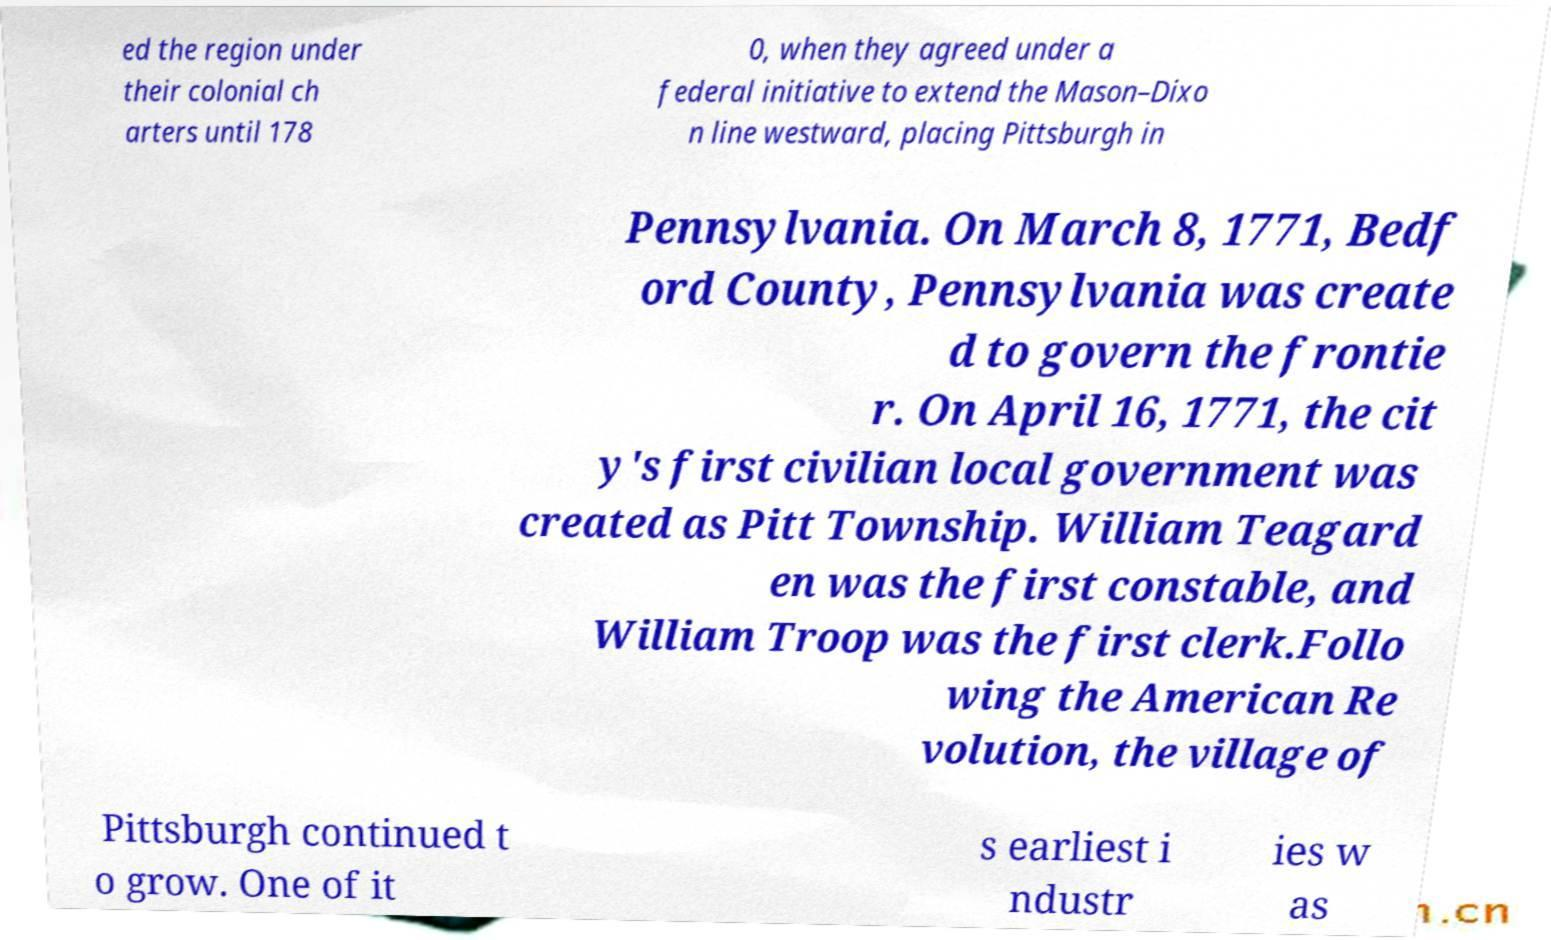Can you read and provide the text displayed in the image?This photo seems to have some interesting text. Can you extract and type it out for me? ed the region under their colonial ch arters until 178 0, when they agreed under a federal initiative to extend the Mason–Dixo n line westward, placing Pittsburgh in Pennsylvania. On March 8, 1771, Bedf ord County, Pennsylvania was create d to govern the frontie r. On April 16, 1771, the cit y's first civilian local government was created as Pitt Township. William Teagard en was the first constable, and William Troop was the first clerk.Follo wing the American Re volution, the village of Pittsburgh continued t o grow. One of it s earliest i ndustr ies w as 